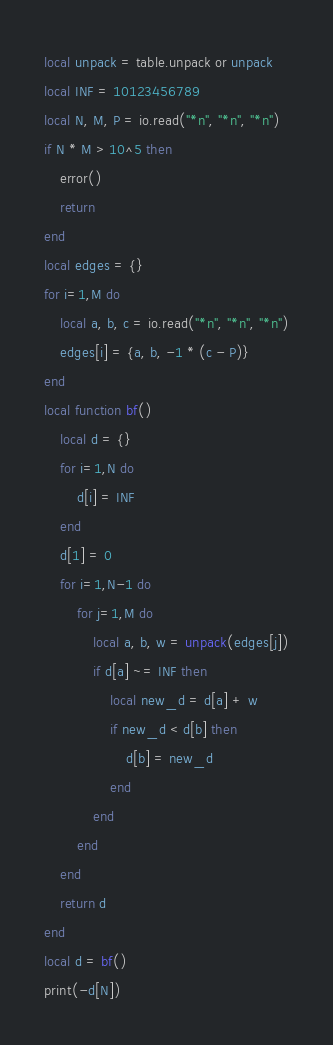Convert code to text. <code><loc_0><loc_0><loc_500><loc_500><_Lua_>local unpack = table.unpack or unpack
local INF = 10123456789
local N, M, P = io.read("*n", "*n", "*n")
if N * M > 10^5 then
    error()
    return
end
local edges = {}
for i=1,M do
    local a, b, c = io.read("*n", "*n", "*n")
    edges[i] = {a, b, -1 * (c - P)}
end
local function bf()
    local d = {}
    for i=1,N do
        d[i] = INF
    end
    d[1] = 0
    for i=1,N-1 do
        for j=1,M do
            local a, b, w = unpack(edges[j])
            if d[a] ~= INF then
                local new_d = d[a] + w
                if new_d < d[b] then
                    d[b] = new_d
                end
            end
        end
    end
    return d
end
local d = bf()
print(-d[N])
</code> 